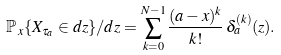<formula> <loc_0><loc_0><loc_500><loc_500>\mathbb { P } _ { \, x } \{ X _ { \tau _ { a } } \in d z \} / d z = \sum _ { k = 0 } ^ { N - 1 } \frac { ( a - x ) ^ { k } } { k ! } \, \delta _ { a } ^ { ( k ) } ( z ) .</formula> 